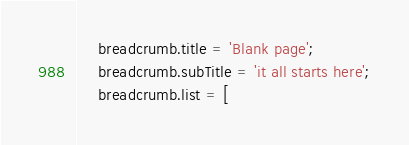<code> <loc_0><loc_0><loc_500><loc_500><_JavaScript_>    breadcrumb.title = 'Blank page';
    breadcrumb.subTitle = 'it all starts here';
    breadcrumb.list = [</code> 